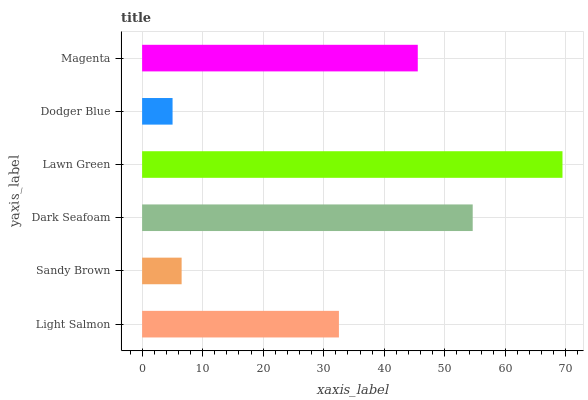Is Dodger Blue the minimum?
Answer yes or no. Yes. Is Lawn Green the maximum?
Answer yes or no. Yes. Is Sandy Brown the minimum?
Answer yes or no. No. Is Sandy Brown the maximum?
Answer yes or no. No. Is Light Salmon greater than Sandy Brown?
Answer yes or no. Yes. Is Sandy Brown less than Light Salmon?
Answer yes or no. Yes. Is Sandy Brown greater than Light Salmon?
Answer yes or no. No. Is Light Salmon less than Sandy Brown?
Answer yes or no. No. Is Magenta the high median?
Answer yes or no. Yes. Is Light Salmon the low median?
Answer yes or no. Yes. Is Sandy Brown the high median?
Answer yes or no. No. Is Lawn Green the low median?
Answer yes or no. No. 